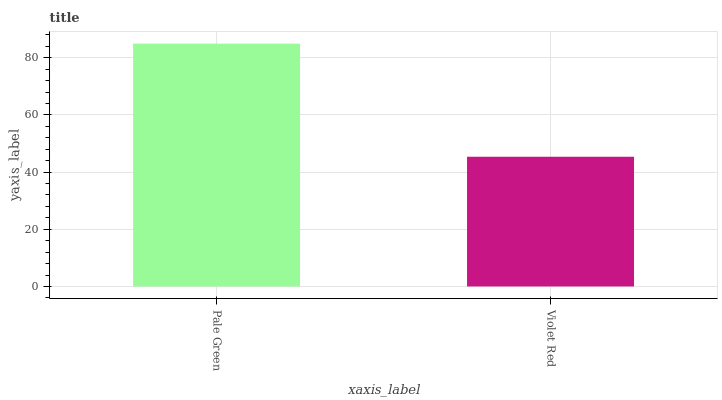Is Violet Red the minimum?
Answer yes or no. Yes. Is Pale Green the maximum?
Answer yes or no. Yes. Is Violet Red the maximum?
Answer yes or no. No. Is Pale Green greater than Violet Red?
Answer yes or no. Yes. Is Violet Red less than Pale Green?
Answer yes or no. Yes. Is Violet Red greater than Pale Green?
Answer yes or no. No. Is Pale Green less than Violet Red?
Answer yes or no. No. Is Pale Green the high median?
Answer yes or no. Yes. Is Violet Red the low median?
Answer yes or no. Yes. Is Violet Red the high median?
Answer yes or no. No. Is Pale Green the low median?
Answer yes or no. No. 